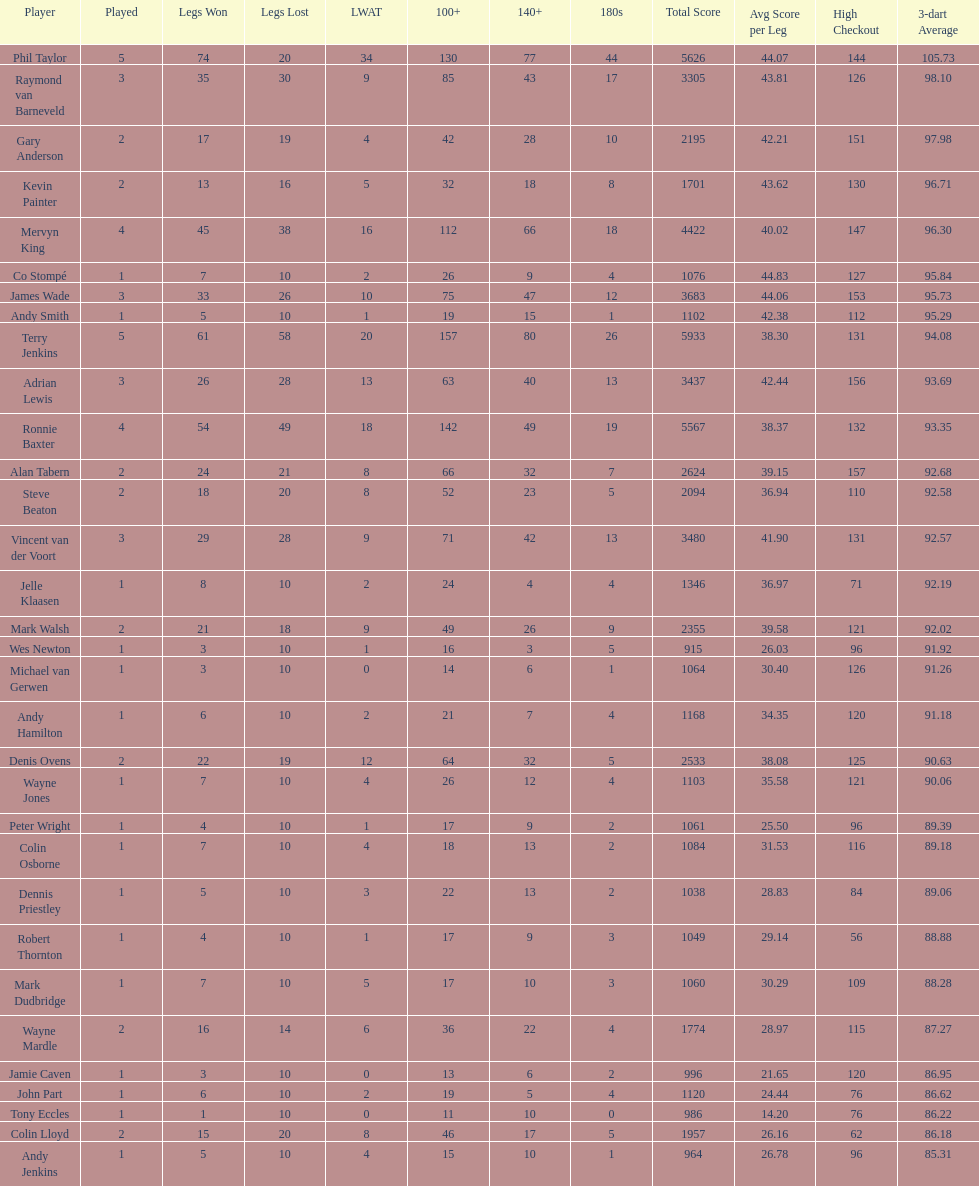Was andy smith or kevin painter's 3-dart average 96.71? Kevin Painter. 